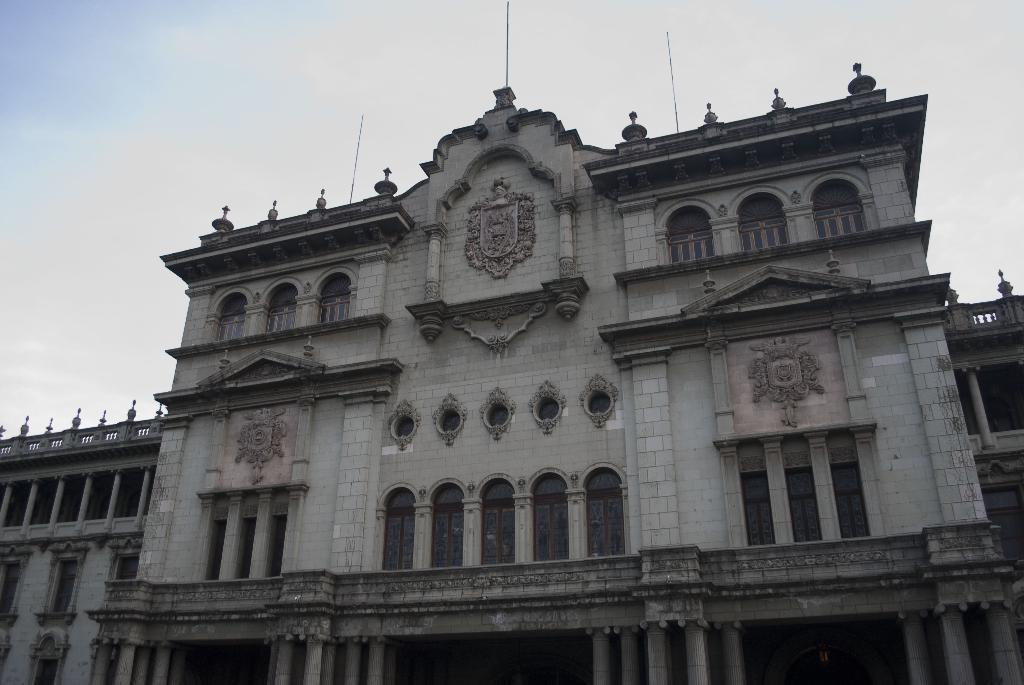Where was the picture taken? The picture was clicked outside. What is the main subject in the center of the image? There is a building in the center of the image. What features can be observed on the building? The building has windows and pillars. What can be seen in the background of the image? The sky is visible in the background of the image. Is there a flame visible in the image? No, there is no flame present in the image. What type of agreement is being signed in the image? There is no indication of an agreement or any signing activity in the image. 